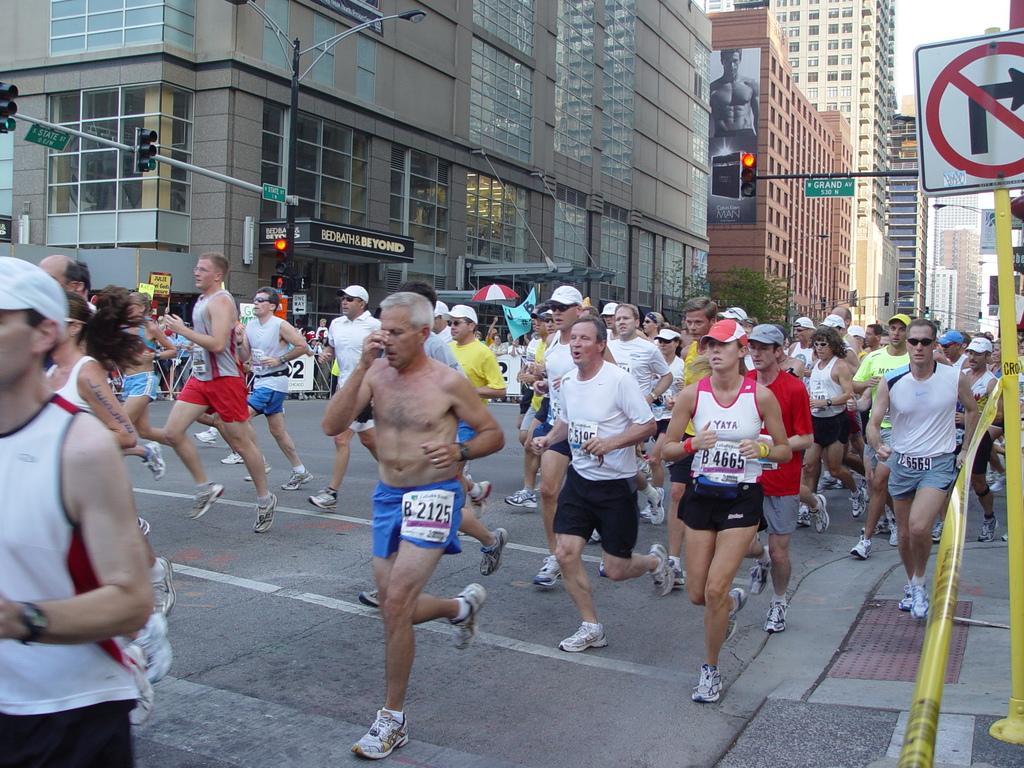Could you give a brief overview of what you see in this image? In this image, we can see people running on the road and some are wearing caps. In the background, there are buildings and we can see traffic lights, street lights, poles, boards, trees and we can see an umbrella and there is a ribbon. 